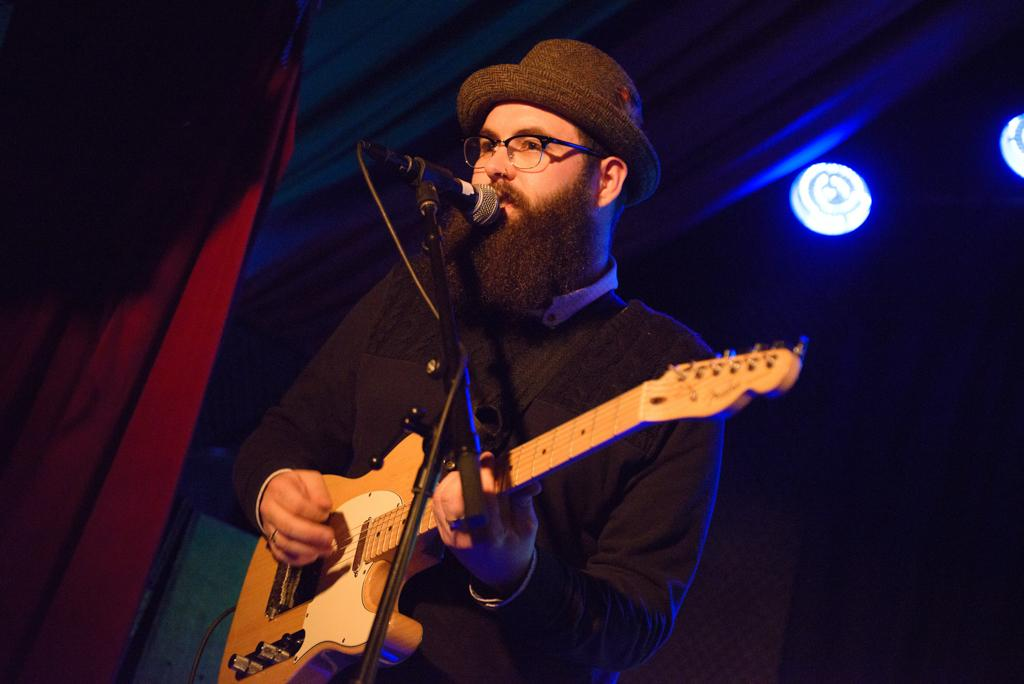What is the man in the image doing? The man is singing and playing a guitar. What is the man using to amplify his voice? The man is in front of a microphone. What can be seen in the background of the image? There are curtains and lights in the background of the image. What type of canvas is the man painting in the image? There is no canvas or painting activity present in the image. What kind of breakfast is the man eating in the image? There is no breakfast or eating activity present in the image. 